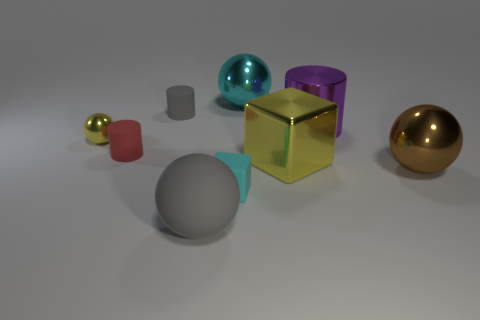Are there fewer small cylinders than spheres?
Make the answer very short. Yes. There is a small gray object; is it the same shape as the cyan object that is to the left of the cyan metal ball?
Give a very brief answer. No. There is a small thing that is behind the small matte cube and on the right side of the red object; what is its shape?
Give a very brief answer. Cylinder. Are there an equal number of small rubber cylinders that are right of the cyan matte object and tiny things that are behind the yellow ball?
Your response must be concise. No. There is a small matte object that is behind the small sphere; is its shape the same as the large purple shiny thing?
Ensure brevity in your answer.  Yes. What number of brown objects are either big metallic spheres or metallic cubes?
Keep it short and to the point. 1. What is the material of the cyan object that is the same shape as the big yellow object?
Give a very brief answer. Rubber. There is a yellow metallic thing behind the small red rubber thing; what shape is it?
Give a very brief answer. Sphere. Is there a cyan object that has the same material as the large brown thing?
Provide a succinct answer. Yes. Do the gray matte cylinder and the gray matte ball have the same size?
Ensure brevity in your answer.  No. 